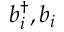Convert formula to latex. <formula><loc_0><loc_0><loc_500><loc_500>b _ { i } ^ { \dagger } , b _ { i }</formula> 